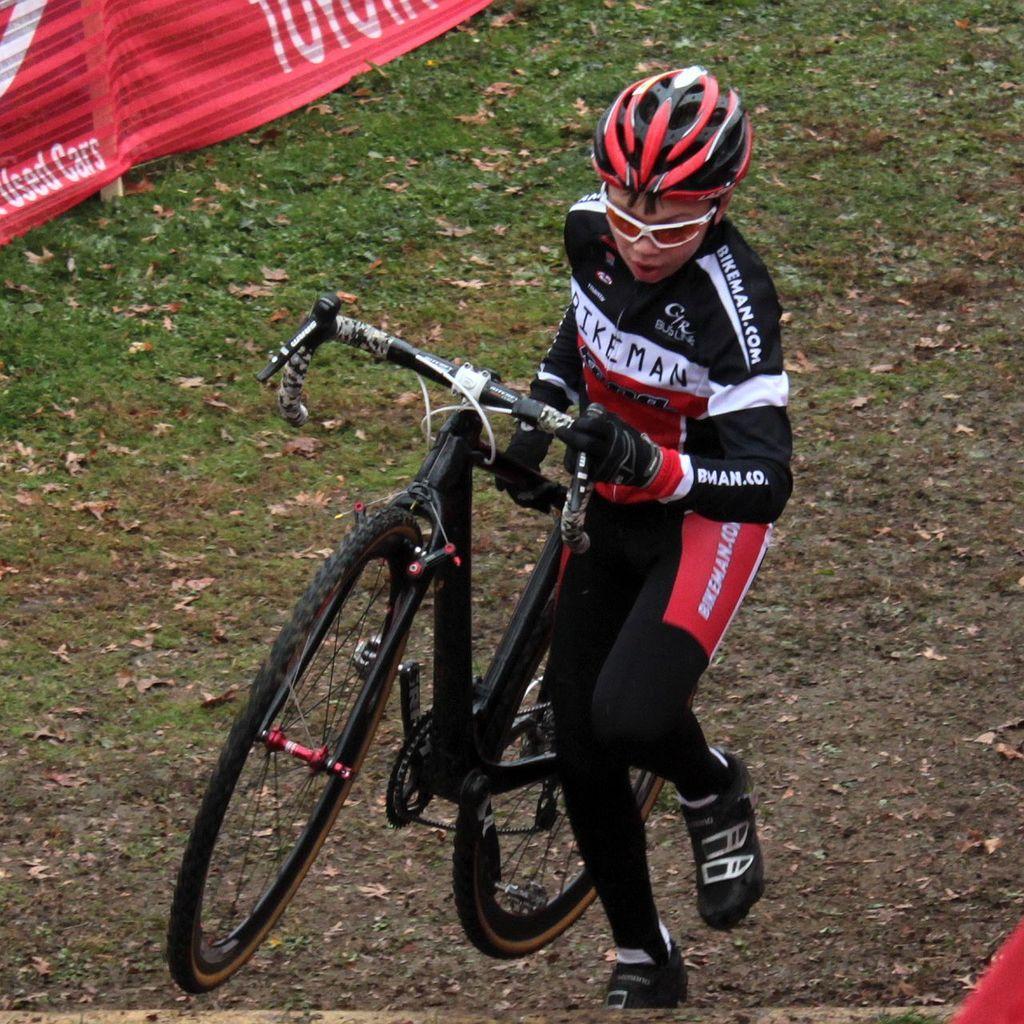Please provide a concise description of this image. In this image there is a person standing and holding a bicycle , and in the background there is grass and a red color cloth. 